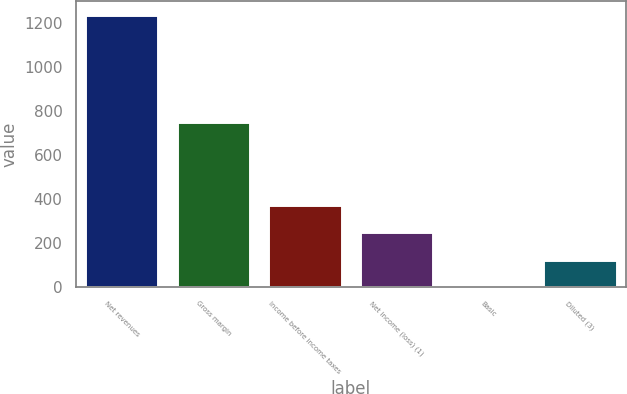Convert chart. <chart><loc_0><loc_0><loc_500><loc_500><bar_chart><fcel>Net revenues<fcel>Gross margin<fcel>Income before income taxes<fcel>Net income (loss) (1)<fcel>Basic<fcel>Diluted (3)<nl><fcel>1239.5<fcel>751.2<fcel>372.13<fcel>248.22<fcel>0.4<fcel>124.31<nl></chart> 